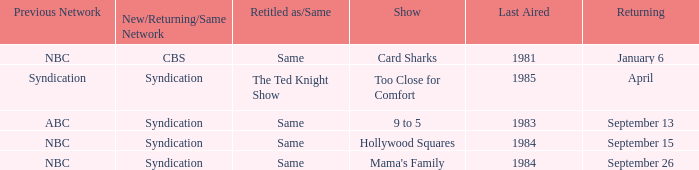When was the show 9 to 5 returning? September 13. 